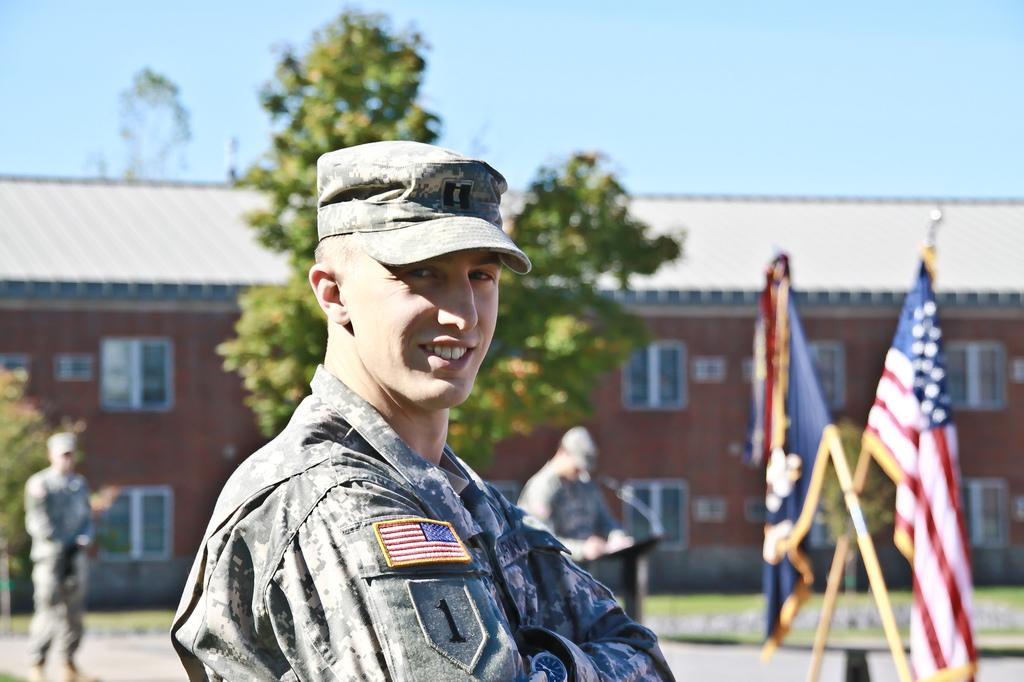What is the main subject of the image? The main subject of the image is a man. What is the man wearing in the image? The man is wearing an army dress and a cap. What can be seen in the background of the image? There are flags, two persons, trees, a building, and the sky visible in the background of the image. What type of plate is being used to serve the birthday cake in the image? There is no plate or birthday cake present in the image. Can you describe the rose that is being held by the man in the image? There is no rose present in the image; the man is wearing an army dress and a cap. 